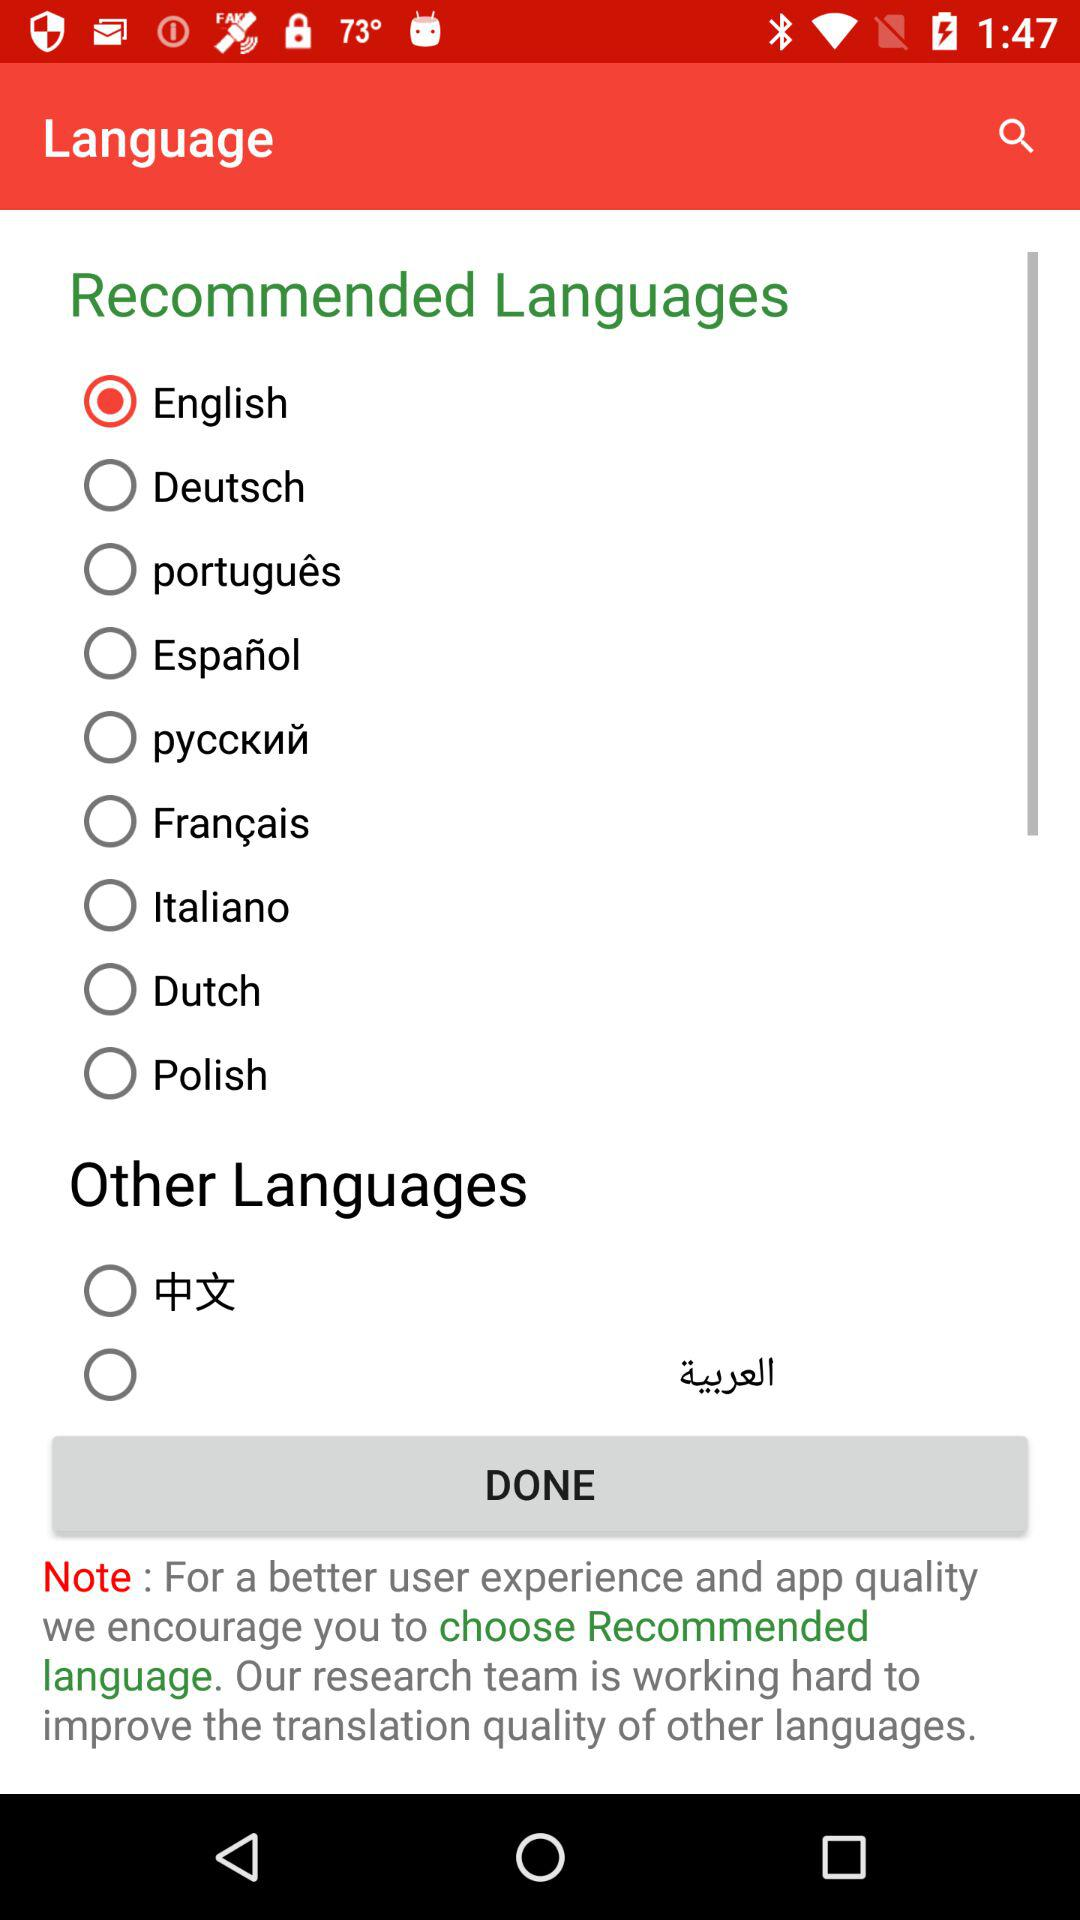Which option is selected? The selected option is English. 